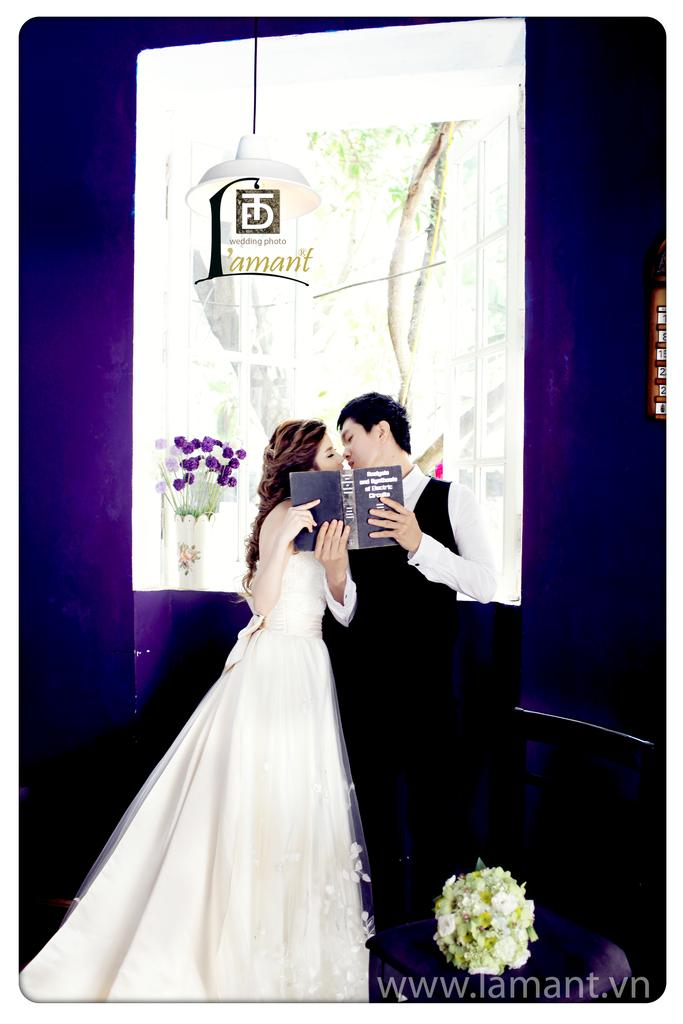Who are the two people in the center of the image? There is a man and a woman in the center of the image. What are the man and woman holding in the image? The man and woman are holding a book. What can be seen in the background of the image? There is an advertisement in the background of the image. What is located at the bottom of the image? There is a bouquet at the bottom of the image. What type of linen is draped over the tent in the background? There is no tent or linen present in the image. How many tubs are visible in the image? There are no tubs visible in the image. 